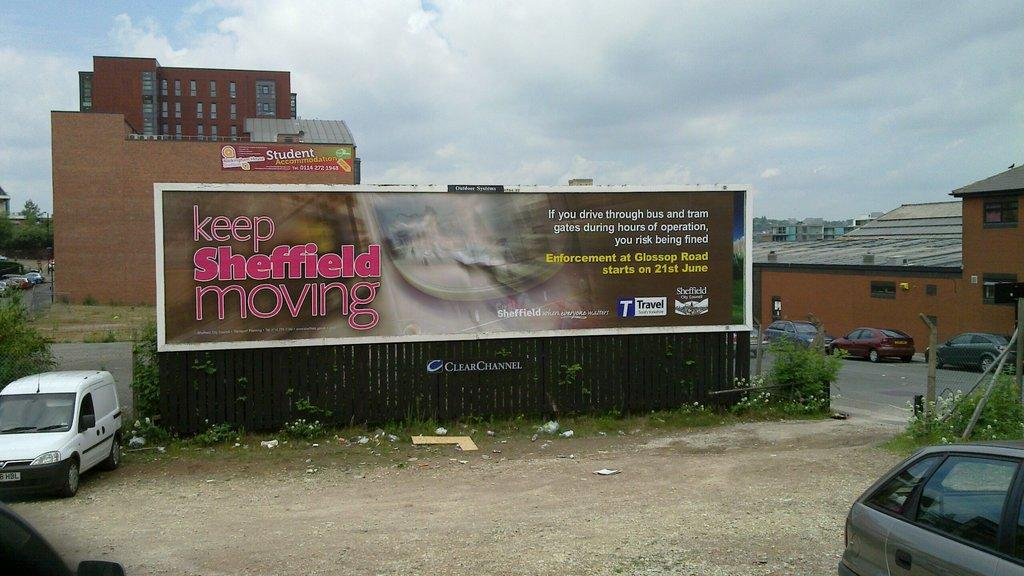<image>
Share a concise interpretation of the image provided. A billboard in a messy city says to keep Sheffield moving. 